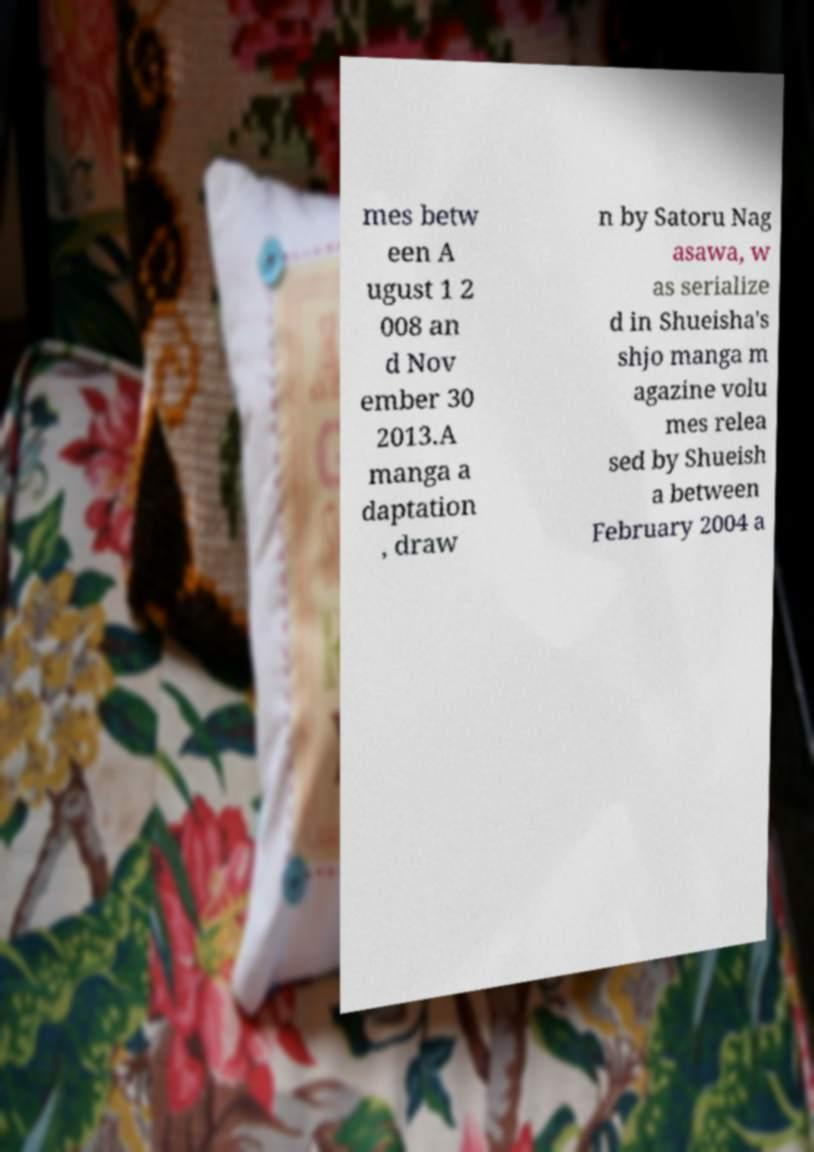Can you accurately transcribe the text from the provided image for me? mes betw een A ugust 1 2 008 an d Nov ember 30 2013.A manga a daptation , draw n by Satoru Nag asawa, w as serialize d in Shueisha's shjo manga m agazine volu mes relea sed by Shueish a between February 2004 a 